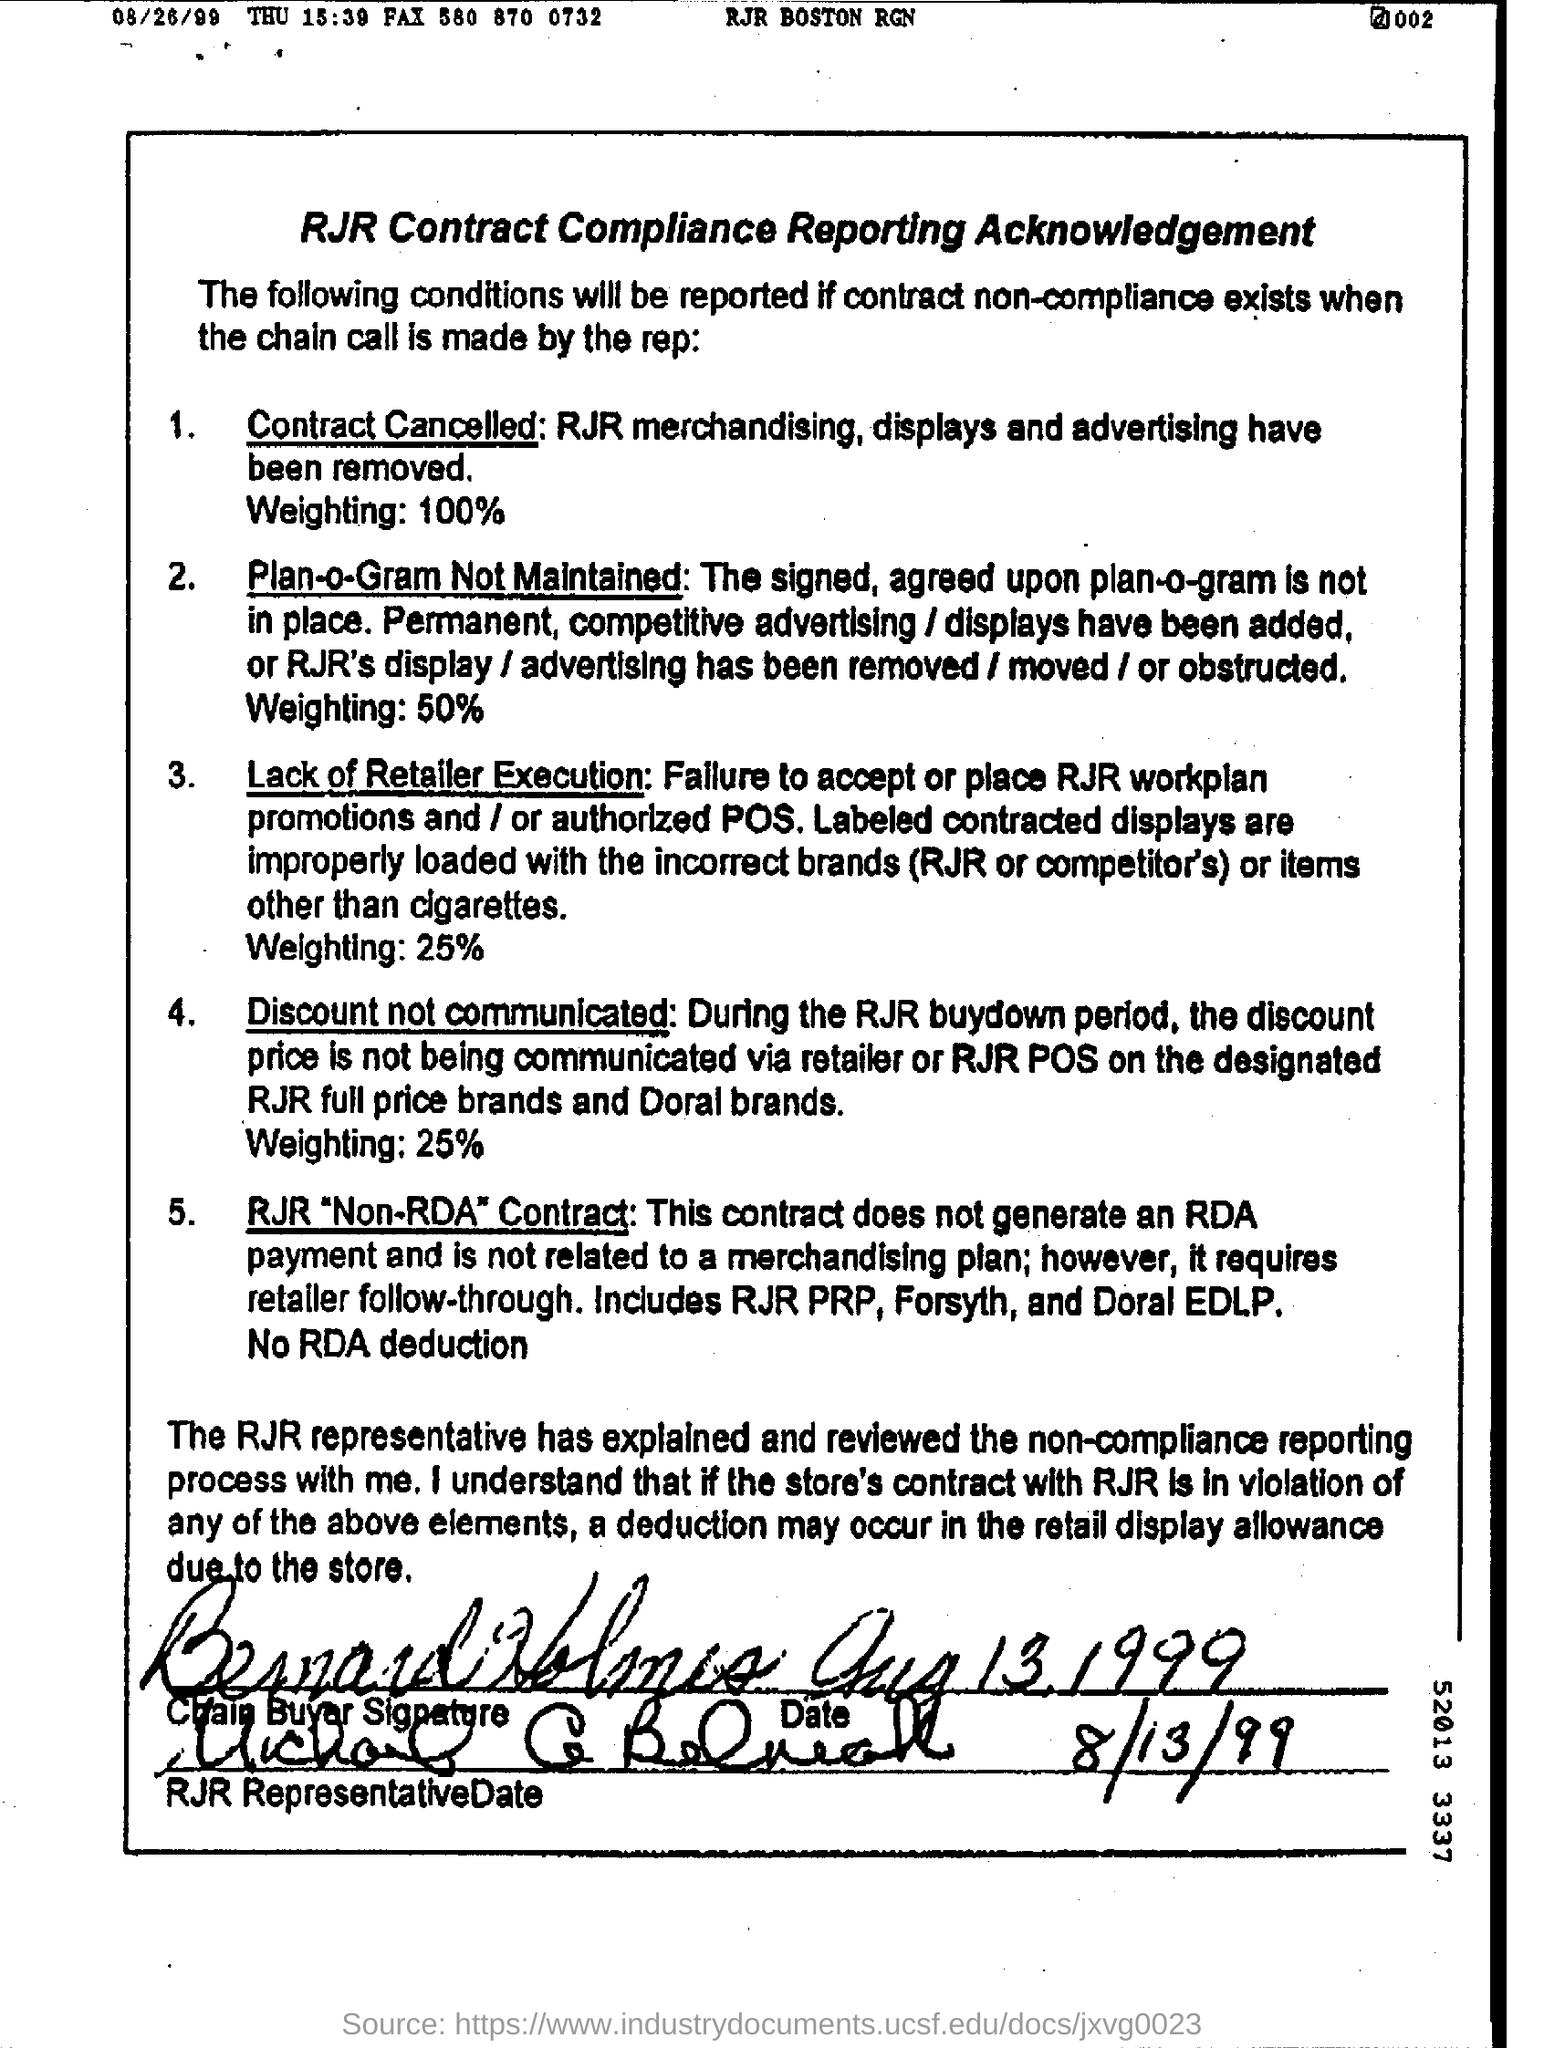List a handful of essential elements in this visual. If a contract is cancelled, the amount is equal to 100% of the weighting. On August 26th, 1999, it was a Thursday. 